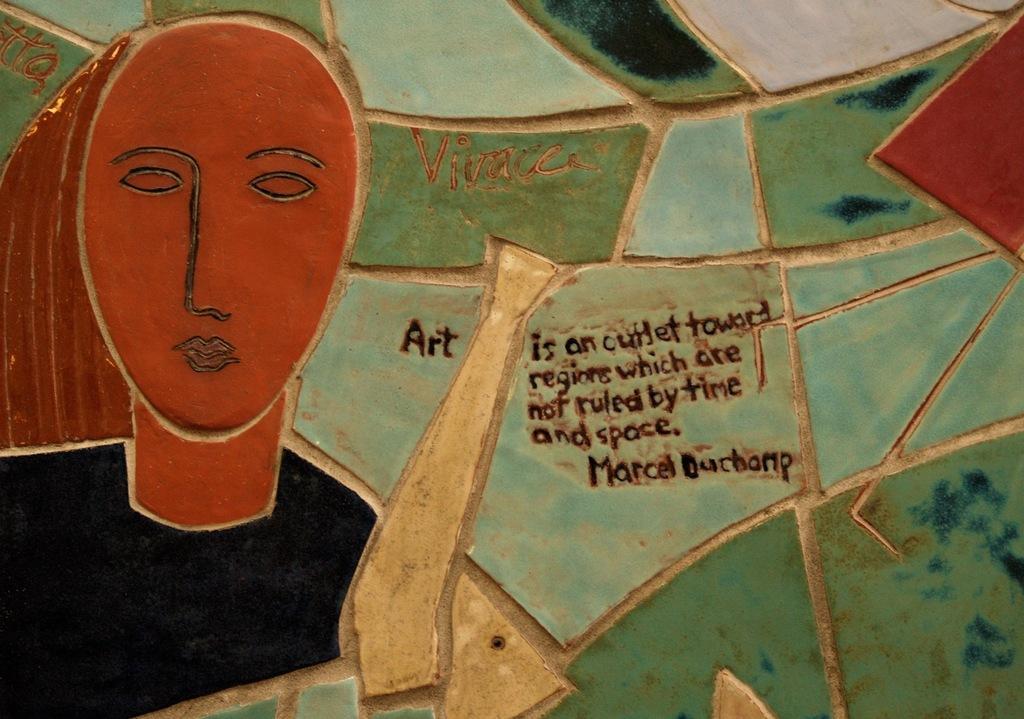Please provide a concise description of this image. In this image in the center there is a wall, on the wall there is some text and some painting. 